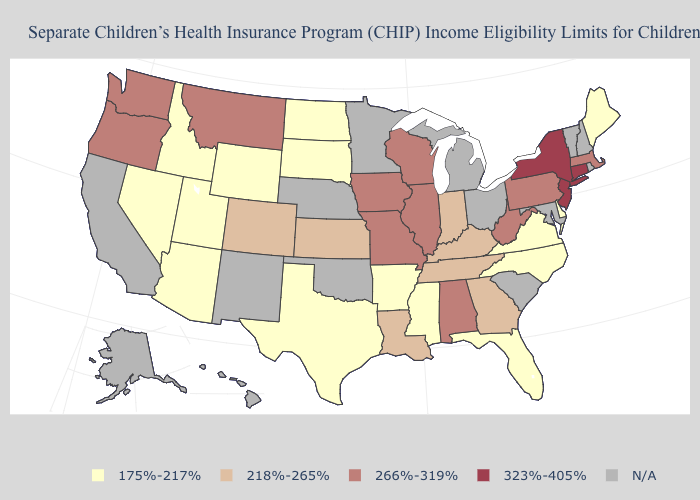What is the value of Ohio?
Short answer required. N/A. Name the states that have a value in the range 218%-265%?
Be succinct. Colorado, Georgia, Indiana, Kansas, Kentucky, Louisiana, Tennessee. Which states have the lowest value in the West?
Answer briefly. Arizona, Idaho, Nevada, Utah, Wyoming. Among the states that border Maryland , does Delaware have the lowest value?
Concise answer only. Yes. What is the value of South Carolina?
Concise answer only. N/A. What is the value of New York?
Be succinct. 323%-405%. Which states have the highest value in the USA?
Write a very short answer. Connecticut, New Jersey, New York. Does Connecticut have the highest value in the USA?
Be succinct. Yes. What is the value of Washington?
Concise answer only. 266%-319%. What is the value of Pennsylvania?
Write a very short answer. 266%-319%. Does New York have the highest value in the USA?
Keep it brief. Yes. Name the states that have a value in the range 218%-265%?
Give a very brief answer. Colorado, Georgia, Indiana, Kansas, Kentucky, Louisiana, Tennessee. Name the states that have a value in the range 323%-405%?
Short answer required. Connecticut, New Jersey, New York. What is the highest value in states that border Alabama?
Answer briefly. 218%-265%. 